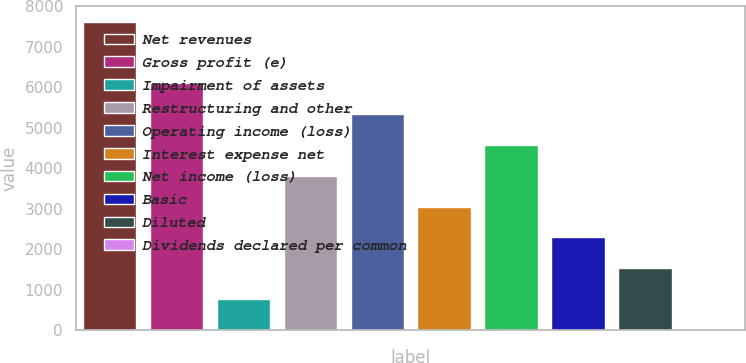<chart> <loc_0><loc_0><loc_500><loc_500><bar_chart><fcel>Net revenues<fcel>Gross profit (e)<fcel>Impairment of assets<fcel>Restructuring and other<fcel>Operating income (loss)<fcel>Interest expense net<fcel>Net income (loss)<fcel>Basic<fcel>Diluted<fcel>Dividends declared per common<nl><fcel>7620.3<fcel>6096.61<fcel>763.7<fcel>3811.07<fcel>5334.76<fcel>3049.23<fcel>4572.91<fcel>2287.39<fcel>1525.55<fcel>1.85<nl></chart> 